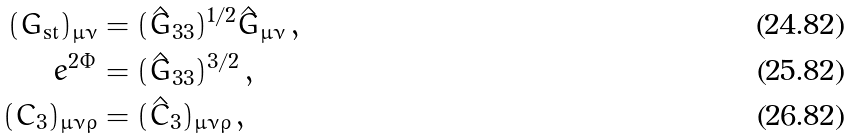<formula> <loc_0><loc_0><loc_500><loc_500>( G _ { \text {st} } ) _ { \mu \nu } & = ( \hat { G } _ { 3 3 } ) ^ { 1 / 2 } \hat { G } _ { \mu \nu } \, , \\ e ^ { 2 \Phi } & = ( \hat { G } _ { 3 3 } ) ^ { 3 / 2 } \, , \\ ( C _ { 3 } ) _ { \mu \nu \rho } & = ( \hat { C } _ { 3 } ) _ { \mu \nu \rho } \, ,</formula> 